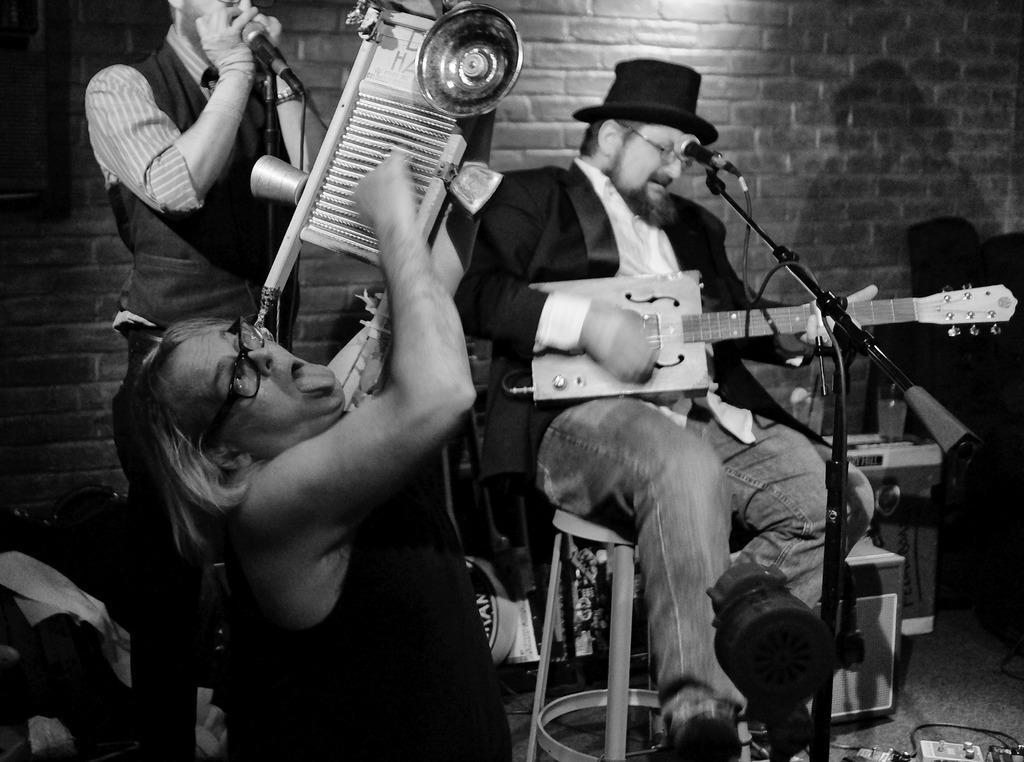Please provide a concise description of this image. A black and white picture. This man is standing in-front of mic. This man is playing a musical instrument. This man is sitting on a chair and plays a guitar in-front of mic. 